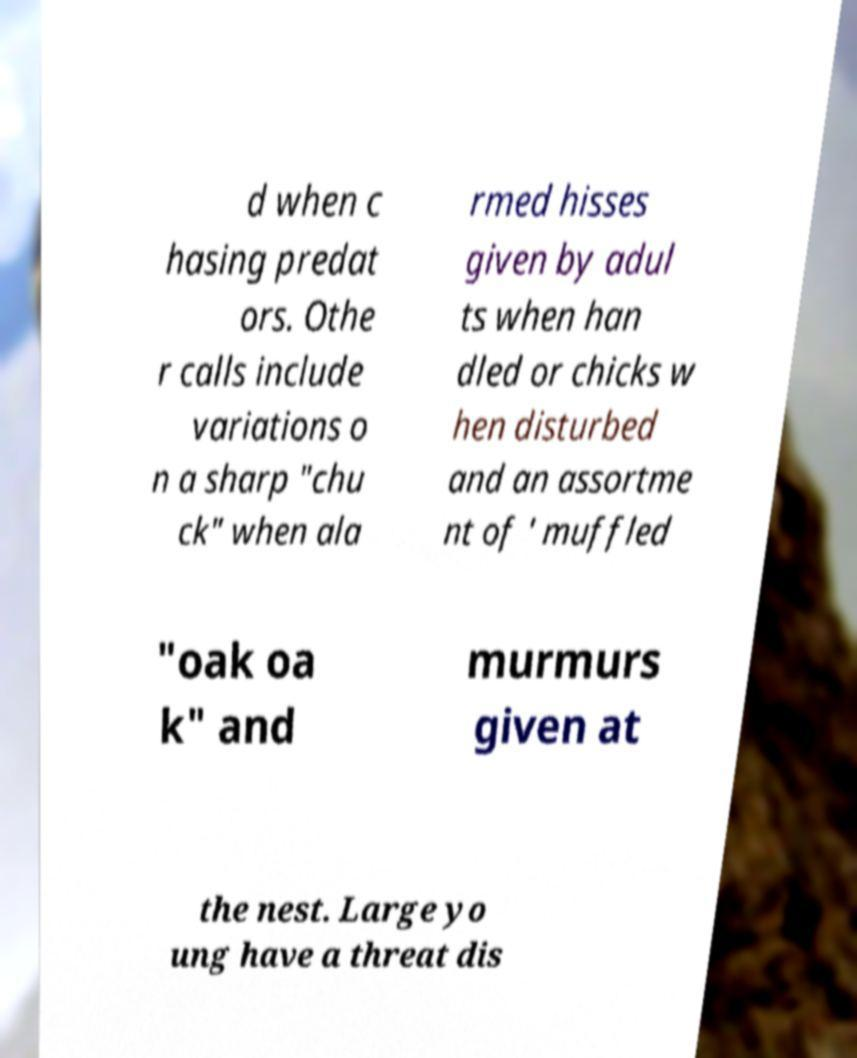Please read and relay the text visible in this image. What does it say? d when c hasing predat ors. Othe r calls include variations o n a sharp "chu ck" when ala rmed hisses given by adul ts when han dled or chicks w hen disturbed and an assortme nt of ' muffled "oak oa k" and murmurs given at the nest. Large yo ung have a threat dis 